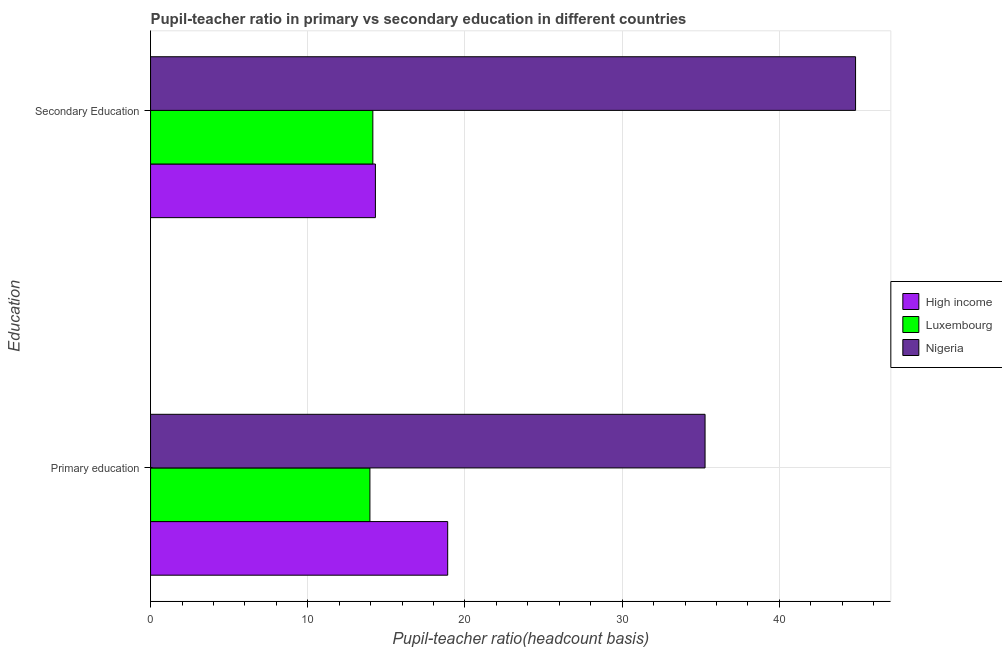Are the number of bars per tick equal to the number of legend labels?
Offer a terse response. Yes. Are the number of bars on each tick of the Y-axis equal?
Provide a short and direct response. Yes. How many bars are there on the 2nd tick from the top?
Provide a succinct answer. 3. How many bars are there on the 1st tick from the bottom?
Your answer should be compact. 3. What is the label of the 2nd group of bars from the top?
Give a very brief answer. Primary education. What is the pupil teacher ratio on secondary education in Luxembourg?
Keep it short and to the point. 14.14. Across all countries, what is the maximum pupil teacher ratio on secondary education?
Offer a very short reply. 44.85. Across all countries, what is the minimum pupil teacher ratio on secondary education?
Give a very brief answer. 14.14. In which country was the pupil-teacher ratio in primary education maximum?
Offer a very short reply. Nigeria. In which country was the pupil-teacher ratio in primary education minimum?
Ensure brevity in your answer.  Luxembourg. What is the total pupil teacher ratio on secondary education in the graph?
Provide a succinct answer. 73.29. What is the difference between the pupil-teacher ratio in primary education in Luxembourg and that in High income?
Your answer should be very brief. -4.95. What is the difference between the pupil teacher ratio on secondary education in Luxembourg and the pupil-teacher ratio in primary education in Nigeria?
Keep it short and to the point. -21.13. What is the average pupil-teacher ratio in primary education per country?
Offer a very short reply. 22.71. What is the difference between the pupil-teacher ratio in primary education and pupil teacher ratio on secondary education in Nigeria?
Offer a terse response. -9.57. What is the ratio of the pupil teacher ratio on secondary education in High income to that in Luxembourg?
Give a very brief answer. 1.01. What does the 2nd bar from the top in Primary education represents?
Provide a short and direct response. Luxembourg. What does the 1st bar from the bottom in Secondary Education represents?
Your answer should be compact. High income. Are all the bars in the graph horizontal?
Your response must be concise. Yes. How many countries are there in the graph?
Provide a succinct answer. 3. Are the values on the major ticks of X-axis written in scientific E-notation?
Ensure brevity in your answer.  No. How are the legend labels stacked?
Your response must be concise. Vertical. What is the title of the graph?
Make the answer very short. Pupil-teacher ratio in primary vs secondary education in different countries. What is the label or title of the X-axis?
Keep it short and to the point. Pupil-teacher ratio(headcount basis). What is the label or title of the Y-axis?
Your response must be concise. Education. What is the Pupil-teacher ratio(headcount basis) of High income in Primary education?
Provide a short and direct response. 18.9. What is the Pupil-teacher ratio(headcount basis) in Luxembourg in Primary education?
Your answer should be compact. 13.95. What is the Pupil-teacher ratio(headcount basis) in Nigeria in Primary education?
Offer a terse response. 35.27. What is the Pupil-teacher ratio(headcount basis) in High income in Secondary Education?
Your answer should be compact. 14.3. What is the Pupil-teacher ratio(headcount basis) in Luxembourg in Secondary Education?
Make the answer very short. 14.14. What is the Pupil-teacher ratio(headcount basis) of Nigeria in Secondary Education?
Make the answer very short. 44.85. Across all Education, what is the maximum Pupil-teacher ratio(headcount basis) in High income?
Provide a short and direct response. 18.9. Across all Education, what is the maximum Pupil-teacher ratio(headcount basis) in Luxembourg?
Offer a terse response. 14.14. Across all Education, what is the maximum Pupil-teacher ratio(headcount basis) of Nigeria?
Give a very brief answer. 44.85. Across all Education, what is the minimum Pupil-teacher ratio(headcount basis) in High income?
Your answer should be compact. 14.3. Across all Education, what is the minimum Pupil-teacher ratio(headcount basis) in Luxembourg?
Your answer should be compact. 13.95. Across all Education, what is the minimum Pupil-teacher ratio(headcount basis) in Nigeria?
Your answer should be very brief. 35.27. What is the total Pupil-teacher ratio(headcount basis) in High income in the graph?
Offer a very short reply. 33.2. What is the total Pupil-teacher ratio(headcount basis) of Luxembourg in the graph?
Make the answer very short. 28.09. What is the total Pupil-teacher ratio(headcount basis) in Nigeria in the graph?
Give a very brief answer. 80.12. What is the difference between the Pupil-teacher ratio(headcount basis) of High income in Primary education and that in Secondary Education?
Your answer should be compact. 4.6. What is the difference between the Pupil-teacher ratio(headcount basis) of Luxembourg in Primary education and that in Secondary Education?
Your answer should be compact. -0.19. What is the difference between the Pupil-teacher ratio(headcount basis) of Nigeria in Primary education and that in Secondary Education?
Provide a succinct answer. -9.57. What is the difference between the Pupil-teacher ratio(headcount basis) in High income in Primary education and the Pupil-teacher ratio(headcount basis) in Luxembourg in Secondary Education?
Offer a terse response. 4.76. What is the difference between the Pupil-teacher ratio(headcount basis) of High income in Primary education and the Pupil-teacher ratio(headcount basis) of Nigeria in Secondary Education?
Your response must be concise. -25.95. What is the difference between the Pupil-teacher ratio(headcount basis) of Luxembourg in Primary education and the Pupil-teacher ratio(headcount basis) of Nigeria in Secondary Education?
Your response must be concise. -30.89. What is the average Pupil-teacher ratio(headcount basis) in High income per Education?
Your answer should be compact. 16.6. What is the average Pupil-teacher ratio(headcount basis) in Luxembourg per Education?
Your answer should be very brief. 14.05. What is the average Pupil-teacher ratio(headcount basis) in Nigeria per Education?
Your response must be concise. 40.06. What is the difference between the Pupil-teacher ratio(headcount basis) of High income and Pupil-teacher ratio(headcount basis) of Luxembourg in Primary education?
Your answer should be very brief. 4.95. What is the difference between the Pupil-teacher ratio(headcount basis) in High income and Pupil-teacher ratio(headcount basis) in Nigeria in Primary education?
Your response must be concise. -16.37. What is the difference between the Pupil-teacher ratio(headcount basis) of Luxembourg and Pupil-teacher ratio(headcount basis) of Nigeria in Primary education?
Your answer should be compact. -21.32. What is the difference between the Pupil-teacher ratio(headcount basis) in High income and Pupil-teacher ratio(headcount basis) in Luxembourg in Secondary Education?
Give a very brief answer. 0.16. What is the difference between the Pupil-teacher ratio(headcount basis) of High income and Pupil-teacher ratio(headcount basis) of Nigeria in Secondary Education?
Your response must be concise. -30.54. What is the difference between the Pupil-teacher ratio(headcount basis) in Luxembourg and Pupil-teacher ratio(headcount basis) in Nigeria in Secondary Education?
Provide a succinct answer. -30.71. What is the ratio of the Pupil-teacher ratio(headcount basis) in High income in Primary education to that in Secondary Education?
Provide a short and direct response. 1.32. What is the ratio of the Pupil-teacher ratio(headcount basis) of Luxembourg in Primary education to that in Secondary Education?
Make the answer very short. 0.99. What is the ratio of the Pupil-teacher ratio(headcount basis) in Nigeria in Primary education to that in Secondary Education?
Your answer should be very brief. 0.79. What is the difference between the highest and the second highest Pupil-teacher ratio(headcount basis) of High income?
Provide a succinct answer. 4.6. What is the difference between the highest and the second highest Pupil-teacher ratio(headcount basis) of Luxembourg?
Provide a short and direct response. 0.19. What is the difference between the highest and the second highest Pupil-teacher ratio(headcount basis) of Nigeria?
Offer a terse response. 9.57. What is the difference between the highest and the lowest Pupil-teacher ratio(headcount basis) of High income?
Provide a short and direct response. 4.6. What is the difference between the highest and the lowest Pupil-teacher ratio(headcount basis) of Luxembourg?
Offer a terse response. 0.19. What is the difference between the highest and the lowest Pupil-teacher ratio(headcount basis) of Nigeria?
Provide a short and direct response. 9.57. 